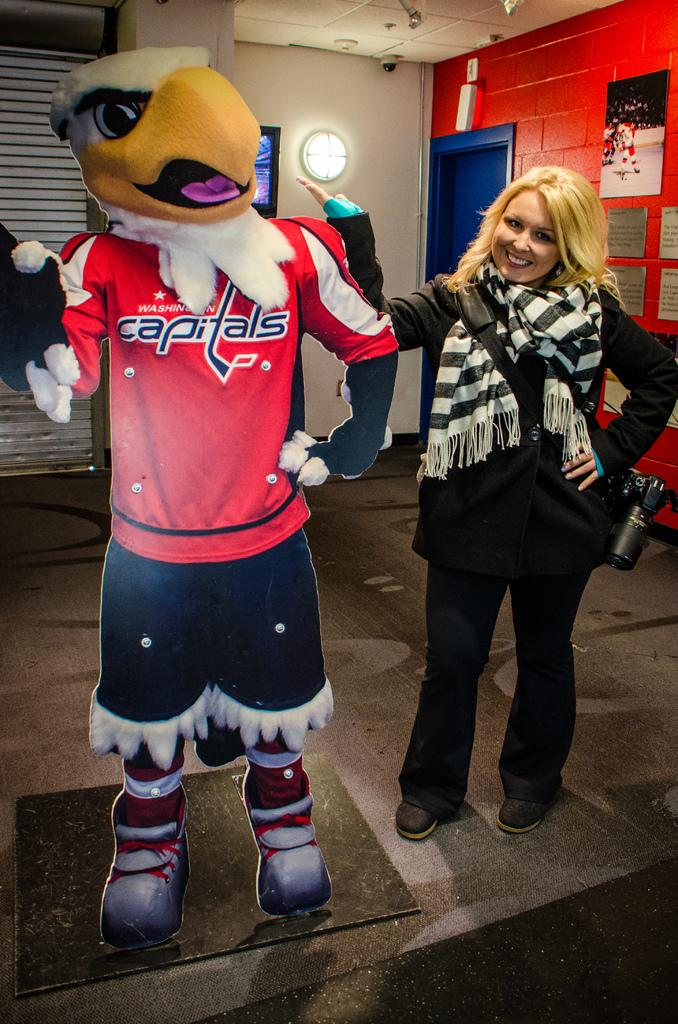Provide a one-sentence caption for the provided image. A blonde woman standing next to a cardboard cutout of an eagle in a Capitals jerseys. 